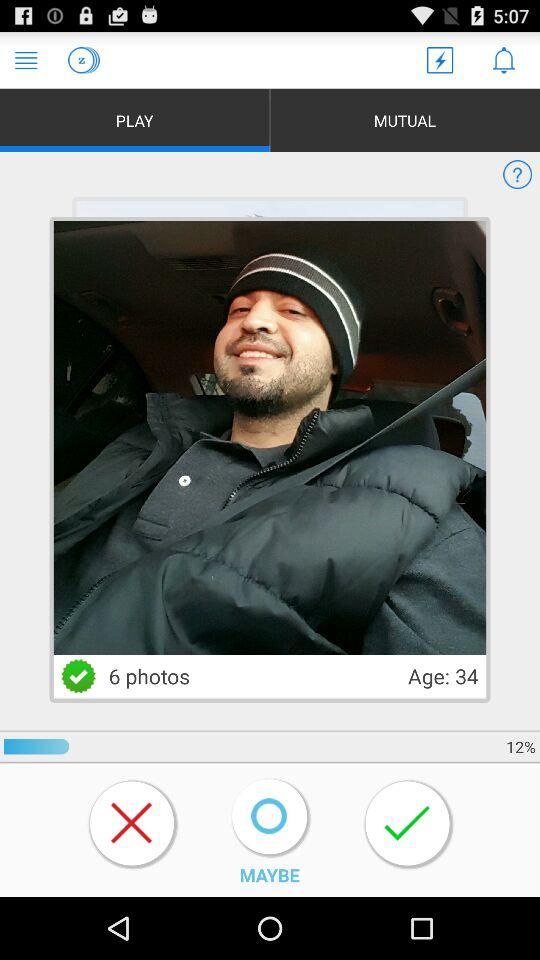How many photos does the user have?
Answer the question using a single word or phrase. 6 